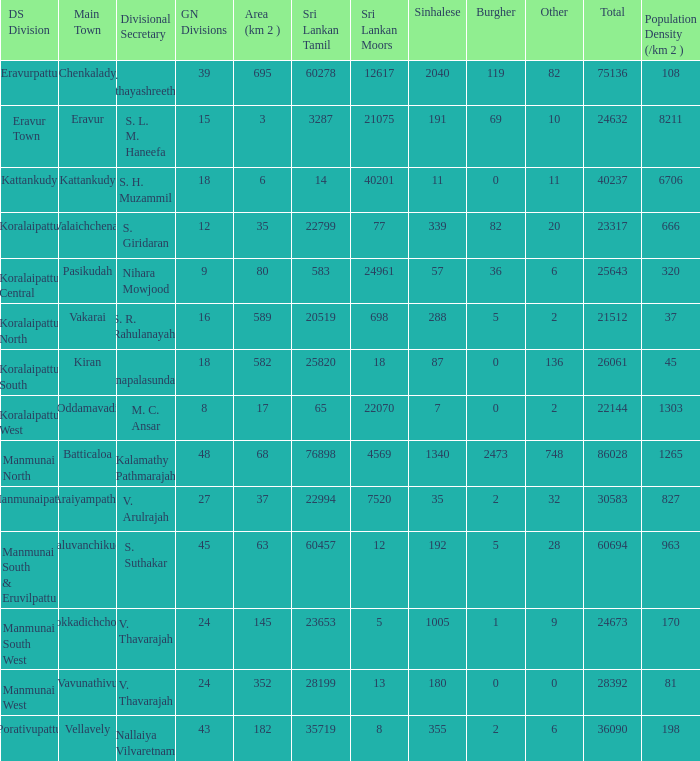What is the name of the DS division where the divisional secretary is S. H. Muzammil? Kattankudy. 